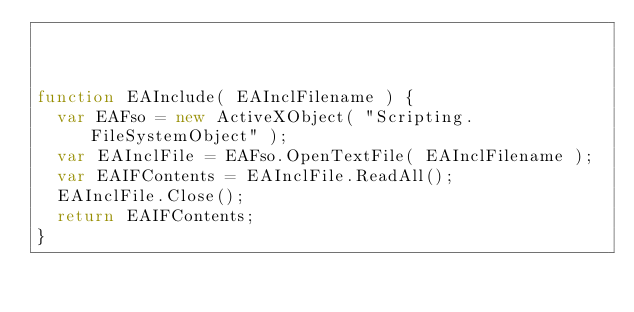Convert code to text. <code><loc_0><loc_0><loc_500><loc_500><_JavaScript_>


function EAInclude( EAInclFilename ) {
  var EAFso = new ActiveXObject( "Scripting.FileSystemObject" );
  var EAInclFile = EAFso.OpenTextFile( EAInclFilename );
  var EAIFContents = EAInclFile.ReadAll();
  EAInclFile.Close();
  return EAIFContents;
}
</code> 